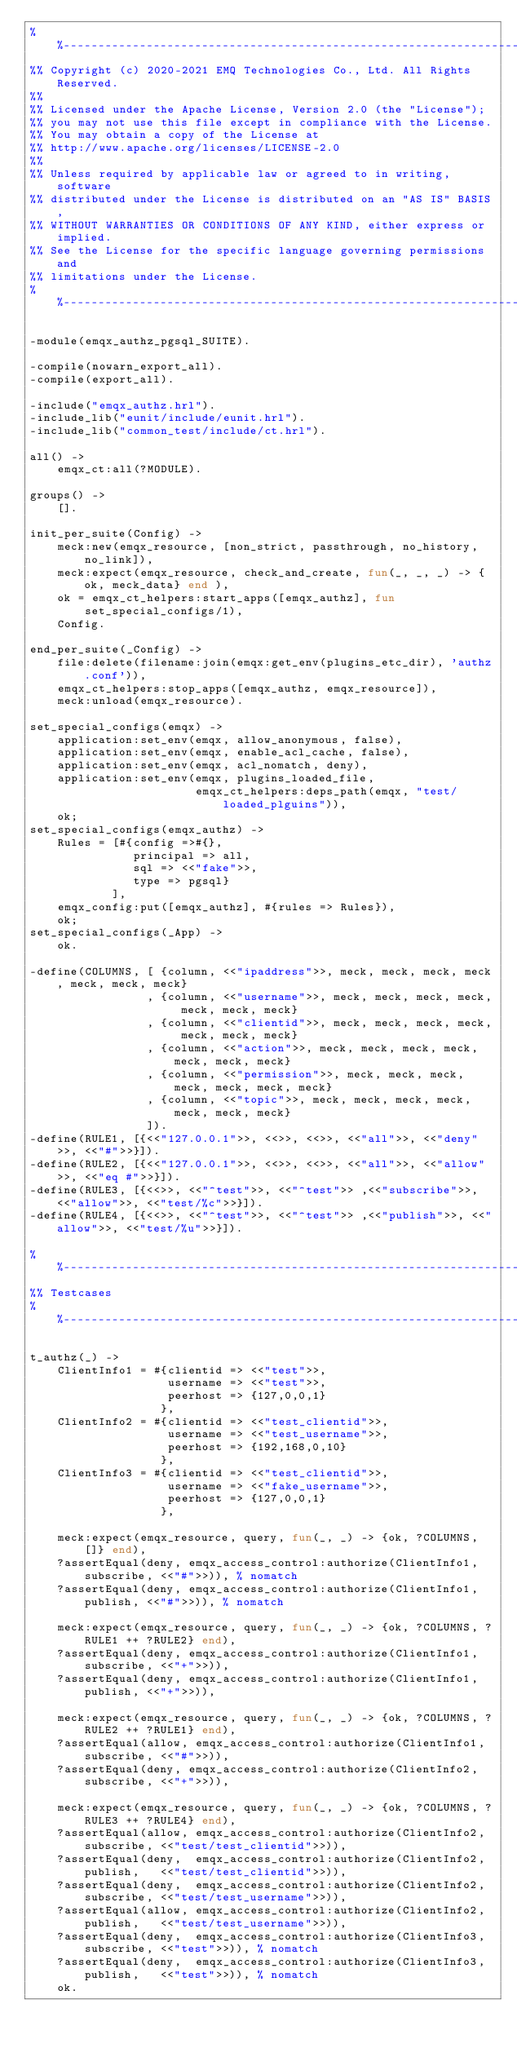Convert code to text. <code><loc_0><loc_0><loc_500><loc_500><_Erlang_>%%--------------------------------------------------------------------
%% Copyright (c) 2020-2021 EMQ Technologies Co., Ltd. All Rights Reserved.
%%
%% Licensed under the Apache License, Version 2.0 (the "License");
%% you may not use this file except in compliance with the License.
%% You may obtain a copy of the License at
%% http://www.apache.org/licenses/LICENSE-2.0
%%
%% Unless required by applicable law or agreed to in writing, software
%% distributed under the License is distributed on an "AS IS" BASIS,
%% WITHOUT WARRANTIES OR CONDITIONS OF ANY KIND, either express or implied.
%% See the License for the specific language governing permissions and
%% limitations under the License.
%%--------------------------------------------------------------------

-module(emqx_authz_pgsql_SUITE).

-compile(nowarn_export_all).
-compile(export_all).

-include("emqx_authz.hrl").
-include_lib("eunit/include/eunit.hrl").
-include_lib("common_test/include/ct.hrl").

all() ->
    emqx_ct:all(?MODULE).

groups() ->
    [].

init_per_suite(Config) ->
    meck:new(emqx_resource, [non_strict, passthrough, no_history, no_link]),
    meck:expect(emqx_resource, check_and_create, fun(_, _, _) -> {ok, meck_data} end ),
    ok = emqx_ct_helpers:start_apps([emqx_authz], fun set_special_configs/1),
    Config.

end_per_suite(_Config) ->
    file:delete(filename:join(emqx:get_env(plugins_etc_dir), 'authz.conf')),
    emqx_ct_helpers:stop_apps([emqx_authz, emqx_resource]),
    meck:unload(emqx_resource).

set_special_configs(emqx) ->
    application:set_env(emqx, allow_anonymous, false),
    application:set_env(emqx, enable_acl_cache, false),
    application:set_env(emqx, acl_nomatch, deny),
    application:set_env(emqx, plugins_loaded_file,
                        emqx_ct_helpers:deps_path(emqx, "test/loaded_plguins")),
    ok;
set_special_configs(emqx_authz) ->
    Rules = [#{config =>#{},
               principal => all,
               sql => <<"fake">>,
               type => pgsql}
            ],
    emqx_config:put([emqx_authz], #{rules => Rules}),
    ok;
set_special_configs(_App) ->
    ok.

-define(COLUMNS, [ {column, <<"ipaddress">>, meck, meck, meck, meck, meck, meck, meck}
                 , {column, <<"username">>, meck, meck, meck, meck, meck, meck, meck}
                 , {column, <<"clientid">>, meck, meck, meck, meck, meck, meck, meck}
                 , {column, <<"action">>, meck, meck, meck, meck, meck, meck, meck}
                 , {column, <<"permission">>, meck, meck, meck, meck, meck, meck, meck}
                 , {column, <<"topic">>, meck, meck, meck, meck, meck, meck, meck}
                 ]).
-define(RULE1, [{<<"127.0.0.1">>, <<>>, <<>>, <<"all">>, <<"deny">>, <<"#">>}]).
-define(RULE2, [{<<"127.0.0.1">>, <<>>, <<>>, <<"all">>, <<"allow">>, <<"eq #">>}]).
-define(RULE3, [{<<>>, <<"^test">>, <<"^test">> ,<<"subscribe">>, <<"allow">>, <<"test/%c">>}]).
-define(RULE4, [{<<>>, <<"^test">>, <<"^test">> ,<<"publish">>, <<"allow">>, <<"test/%u">>}]).

%%------------------------------------------------------------------------------
%% Testcases
%%------------------------------------------------------------------------------

t_authz(_) ->
    ClientInfo1 = #{clientid => <<"test">>,
                    username => <<"test">>,
                    peerhost => {127,0,0,1}
                   },
    ClientInfo2 = #{clientid => <<"test_clientid">>,
                    username => <<"test_username">>,
                    peerhost => {192,168,0,10}
                   },
    ClientInfo3 = #{clientid => <<"test_clientid">>,
                    username => <<"fake_username">>,
                    peerhost => {127,0,0,1}
                   },

    meck:expect(emqx_resource, query, fun(_, _) -> {ok, ?COLUMNS, []} end),
    ?assertEqual(deny, emqx_access_control:authorize(ClientInfo1, subscribe, <<"#">>)), % nomatch
    ?assertEqual(deny, emqx_access_control:authorize(ClientInfo1, publish, <<"#">>)), % nomatch

    meck:expect(emqx_resource, query, fun(_, _) -> {ok, ?COLUMNS, ?RULE1 ++ ?RULE2} end),
    ?assertEqual(deny, emqx_access_control:authorize(ClientInfo1, subscribe, <<"+">>)),
    ?assertEqual(deny, emqx_access_control:authorize(ClientInfo1, publish, <<"+">>)),

    meck:expect(emqx_resource, query, fun(_, _) -> {ok, ?COLUMNS, ?RULE2 ++ ?RULE1} end),
    ?assertEqual(allow, emqx_access_control:authorize(ClientInfo1, subscribe, <<"#">>)),
    ?assertEqual(deny, emqx_access_control:authorize(ClientInfo2, subscribe, <<"+">>)),

    meck:expect(emqx_resource, query, fun(_, _) -> {ok, ?COLUMNS, ?RULE3 ++ ?RULE4} end),
    ?assertEqual(allow, emqx_access_control:authorize(ClientInfo2, subscribe, <<"test/test_clientid">>)),
    ?assertEqual(deny,  emqx_access_control:authorize(ClientInfo2, publish,   <<"test/test_clientid">>)),
    ?assertEqual(deny,  emqx_access_control:authorize(ClientInfo2, subscribe, <<"test/test_username">>)),
    ?assertEqual(allow, emqx_access_control:authorize(ClientInfo2, publish,   <<"test/test_username">>)),
    ?assertEqual(deny,  emqx_access_control:authorize(ClientInfo3, subscribe, <<"test">>)), % nomatch
    ?assertEqual(deny,  emqx_access_control:authorize(ClientInfo3, publish,   <<"test">>)), % nomatch
    ok.

</code> 